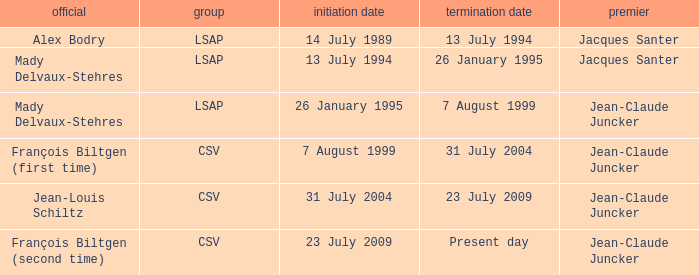Who was the minister for the CSV party with a present day end date? François Biltgen (second time). 